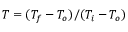Convert formula to latex. <formula><loc_0><loc_0><loc_500><loc_500>T = ( T _ { f } - T _ { o } ) / ( T _ { i } - T _ { o } )</formula> 